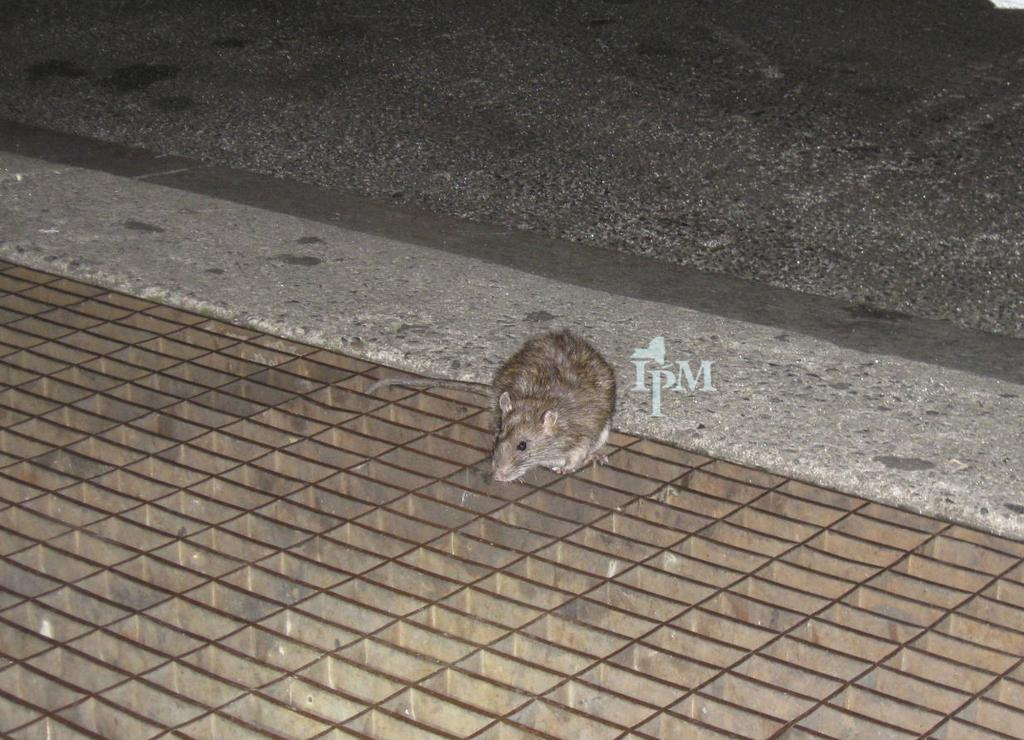What animal is present in the image? There is a rat in the image. What is the rat standing on? The rat is standing on a grill. What can be seen in the distance in the image? There is a road visible in the background of the image. What type of maid can be seen cleaning the rat's cage in the image? There is no maid present in the image, nor is there a rat cage. 